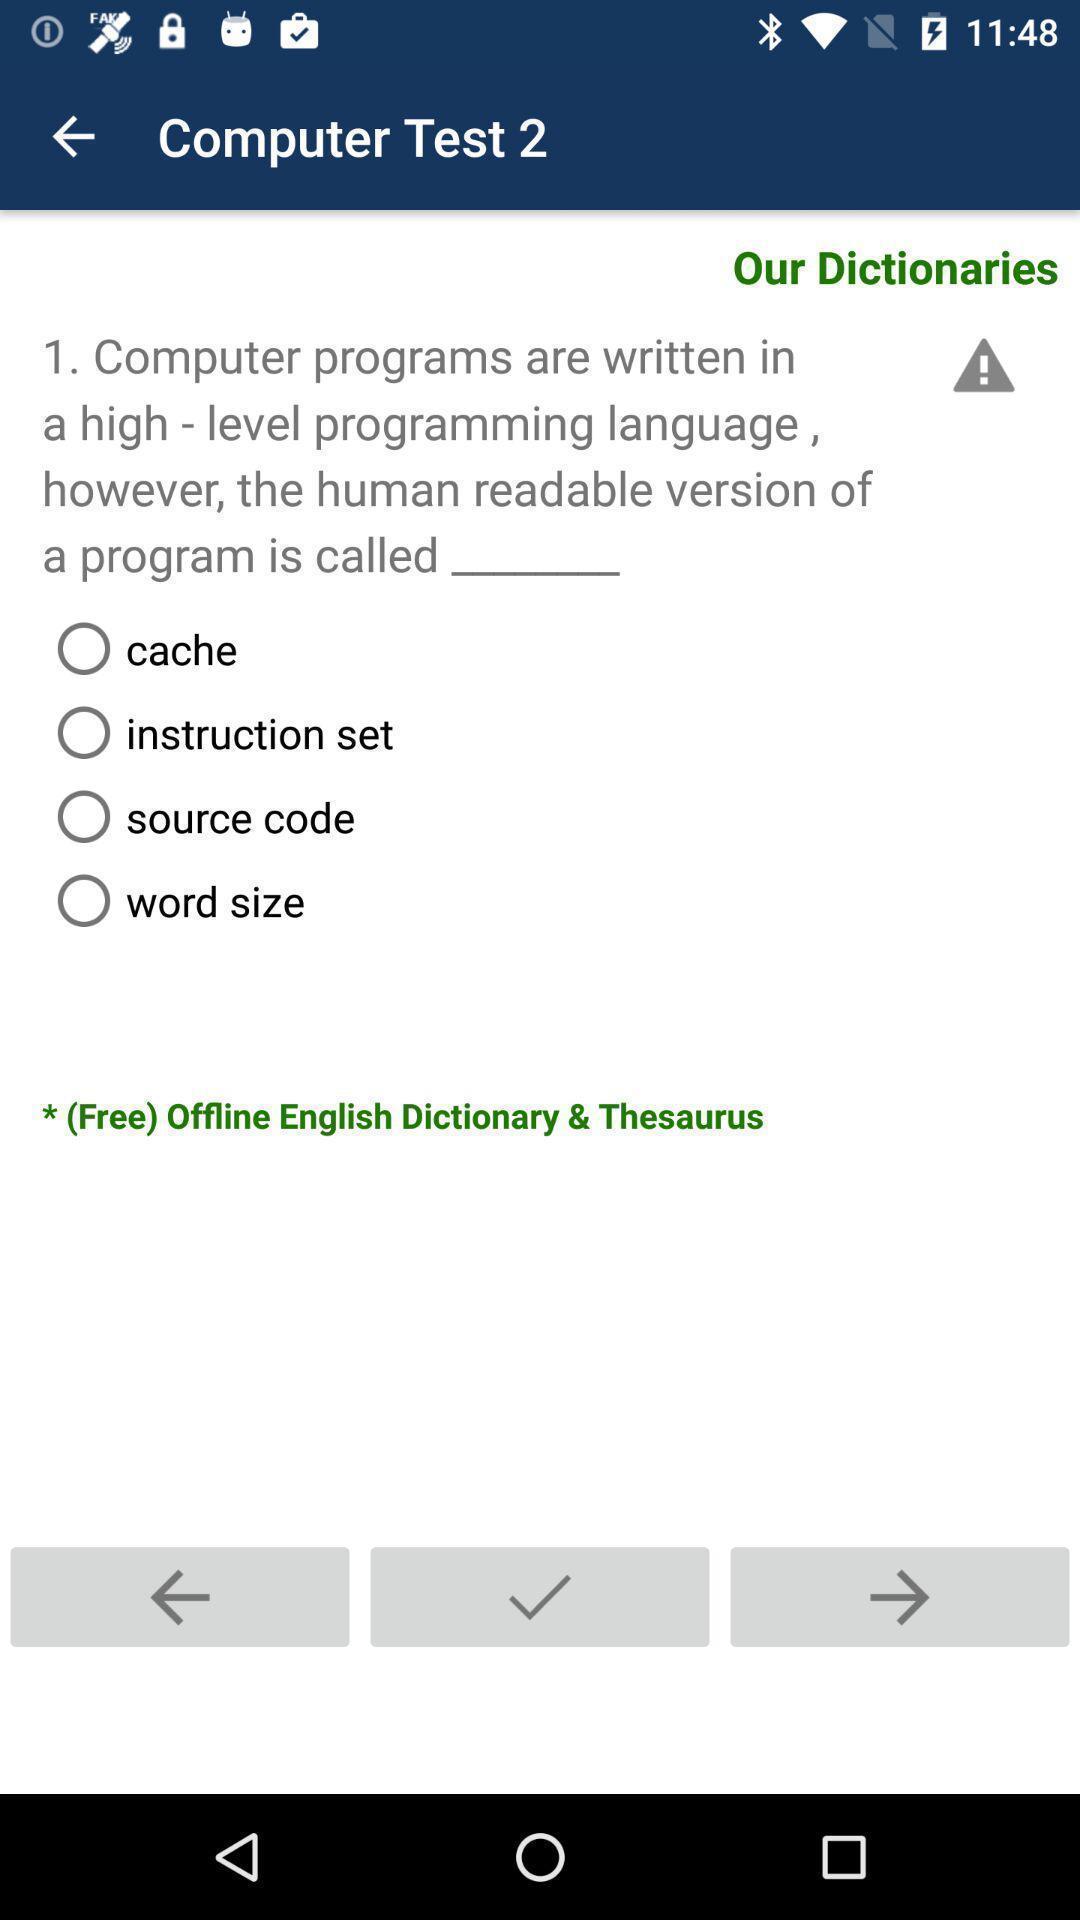Provide a textual representation of this image. Question page of a computer test app. 